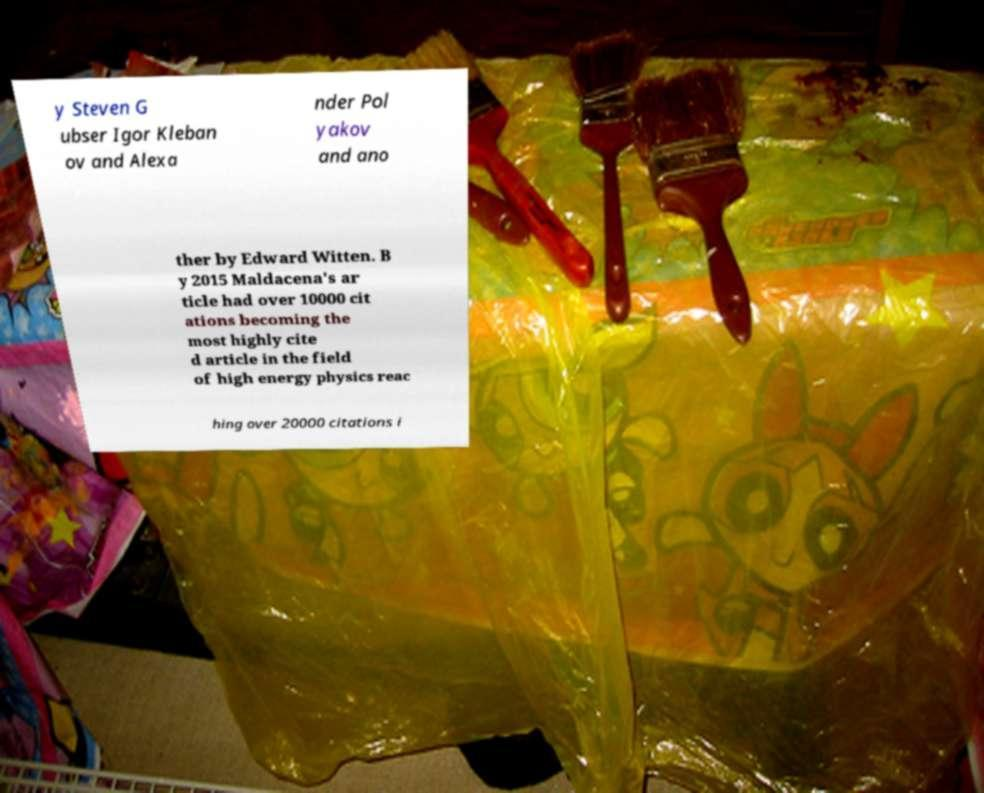Can you accurately transcribe the text from the provided image for me? y Steven G ubser Igor Kleban ov and Alexa nder Pol yakov and ano ther by Edward Witten. B y 2015 Maldacena's ar ticle had over 10000 cit ations becoming the most highly cite d article in the field of high energy physics reac hing over 20000 citations i 